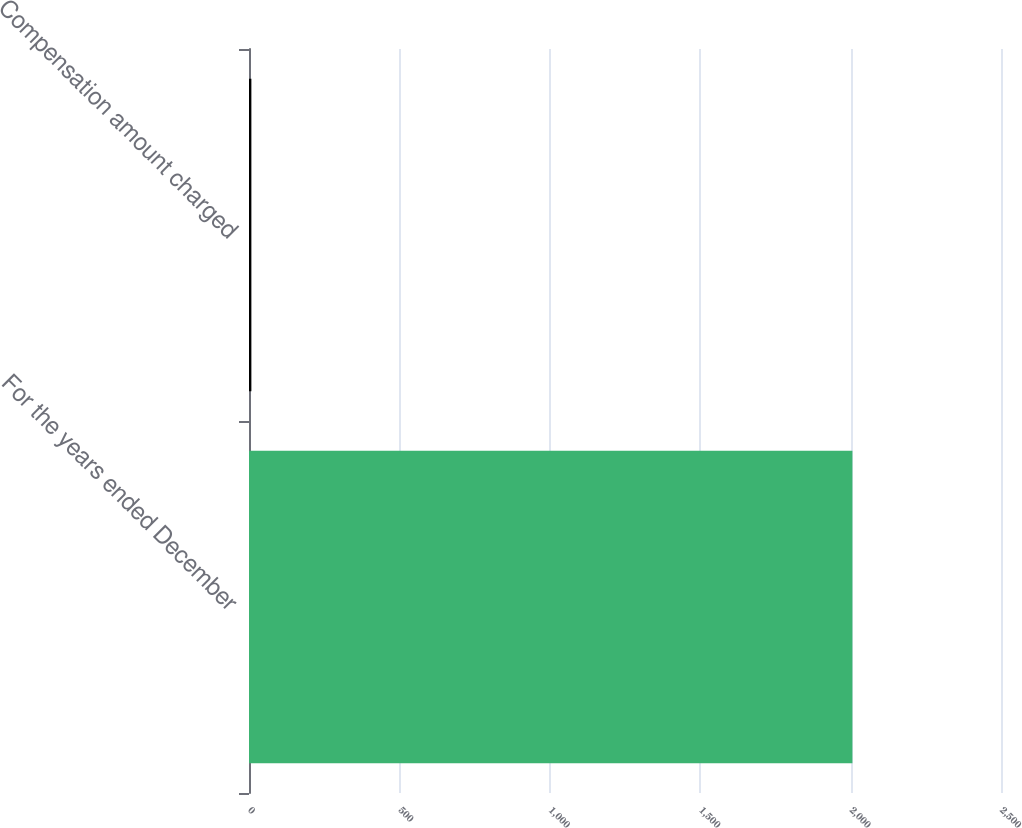Convert chart to OTSL. <chart><loc_0><loc_0><loc_500><loc_500><bar_chart><fcel>For the years ended December<fcel>Compensation amount charged<nl><fcel>2006<fcel>7.9<nl></chart> 